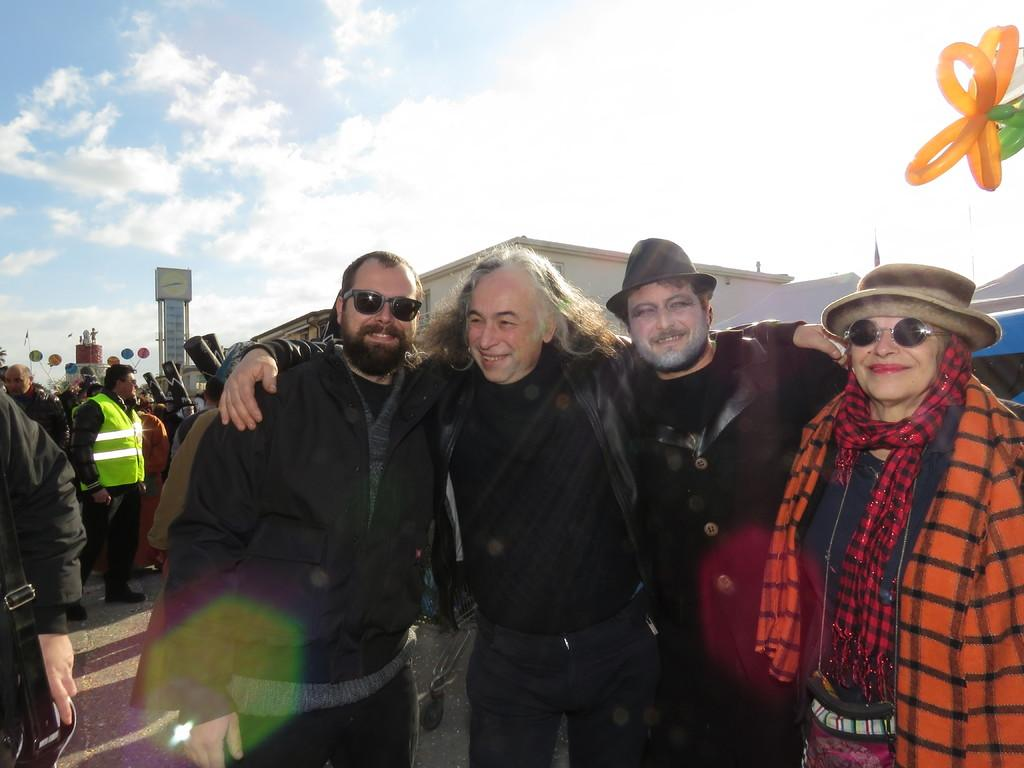How many people are in the image? There are four people in the image. What are the people wearing? The four people are wearing jackets. Are any of the people wearing hats? Yes, two of the people are wearing hats. Can you describe the other people visible in the image? There are other people visible in the image, but their specific characteristics are not mentioned in the facts. What else can be seen in the image besides the people? Balloons are present in the image. What type of tail can be seen on the daughter in the image? There is no mention of a daughter or a tail in the image or the provided facts. 